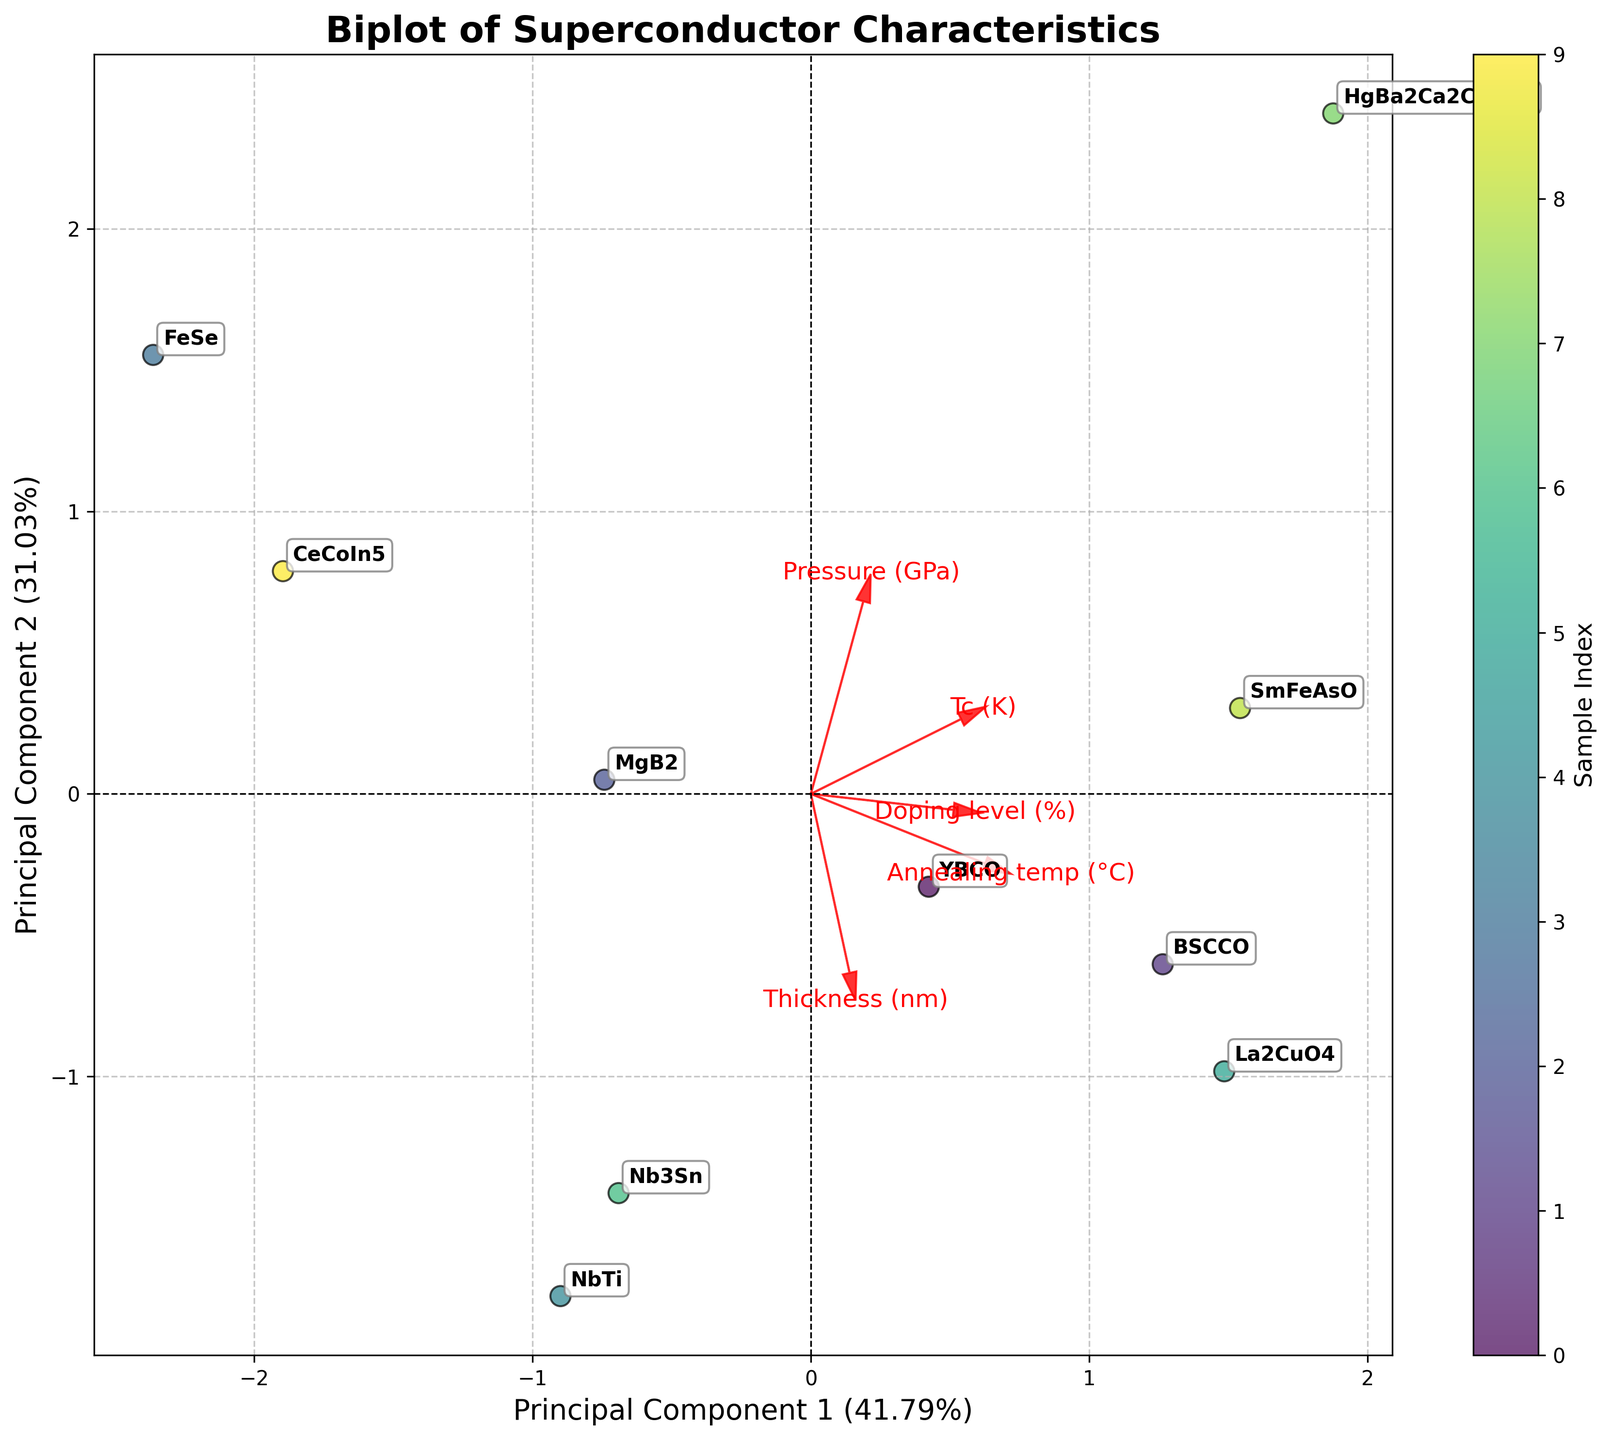Which sample has the highest Tc (K)? Look for the sample with the highest y-coordinate where Tc (K) is displayed.
Answer: HgBa2Ca2Cu3O8 How many principle components are shown on the plot? The axes are labeled "Principal Component 1" and "Principal Component 2."
Answer: 2 Which feature has the longest vector in the direction of Principal Component 1? Observe the red vectors originating from (0,0) along Principal Component 1.
Answer: Tc (K) What does the arrow representing 'Pressure (GPa)' suggest about its correlation with the data? The arrow length and direction indicate how much and in which direction Pressure (GPa) correlates with the principal components. A longer arrow suggests higher correlation.
Answer: Moderate positive correlation Which two samples are closest in the PCA space? Find the two samples with the smallest distance between them on the plot.
Answer: NbTi and Nb3Sn Is 'Annealing temp (°C)' more aligned with Principal Component 1 or Principal Component 2? Compare the direction of the 'Annealing temp (°C)' arrow with the axes.
Answer: Principal Component 1 How much variance is explained by Principal Component 2? Look at the y-axis label to see the percentage of variance explained by Principal Component 2.
Answer: Around 28% Which sample has the lowest value along Principal Component 1? Identify the sample with the smallest x-coordinate.
Answer: NbTi Are 'Thickness (nm)' and 'Doping level (%)' correlated with each other in this biplot? Check if their vectors are pointing in roughly the same or opposite directions.
Answer: Not strongly correlated What does the position of BSCCO suggest about its characteristics? Its position relative to other samples and the feature vectors can provide insights into its characteristics.
Answer: Higher Tc and moderate Pressure and Doping level 